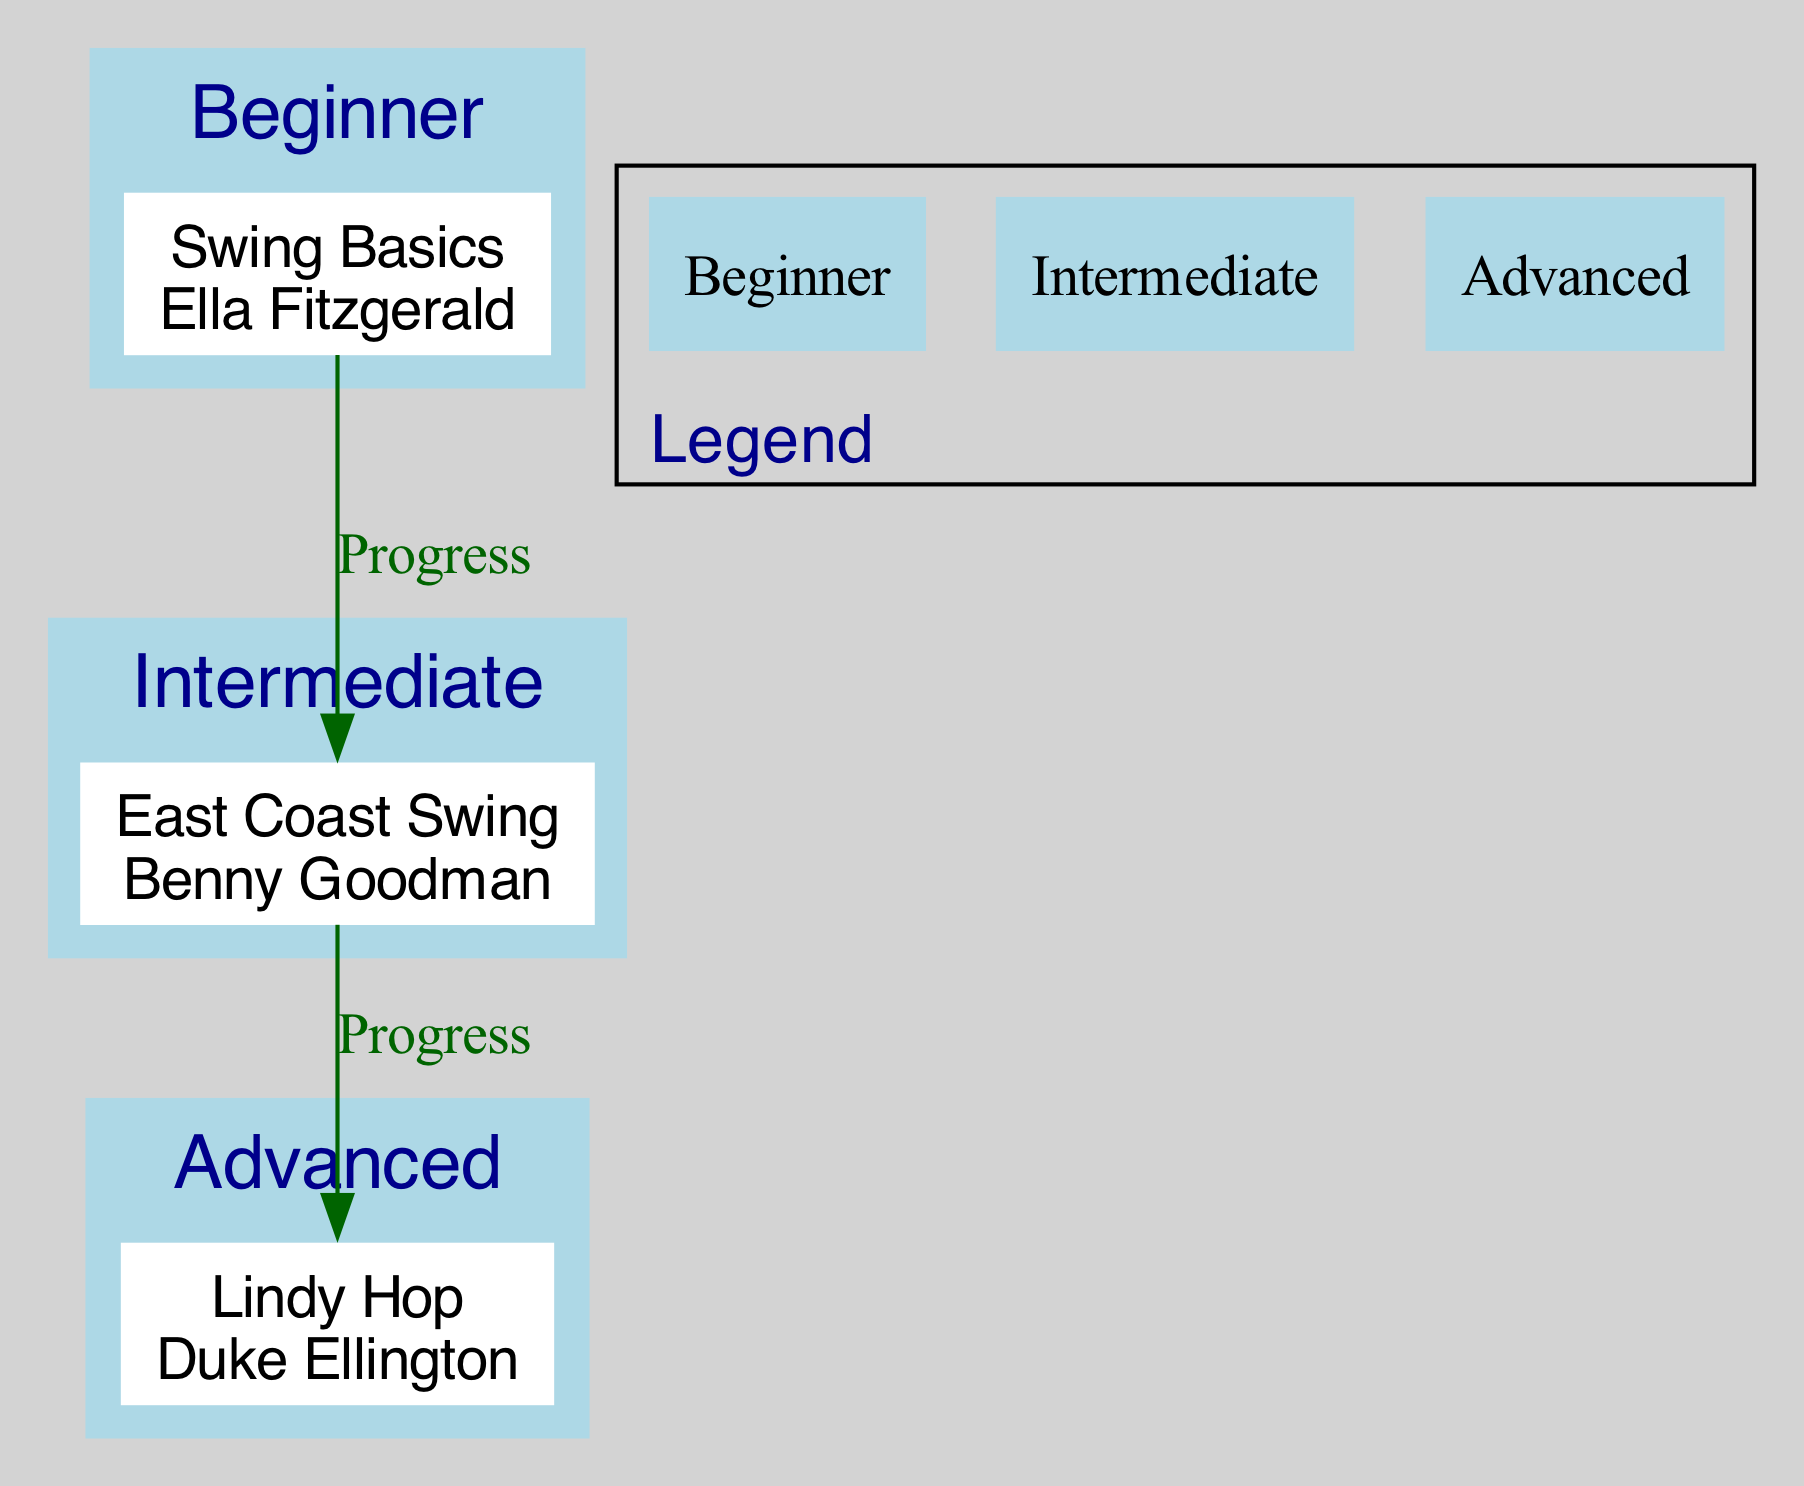What class is assigned to the instructor Ella Fitzgerald? The diagram indicates that Ella Fitzgerald is assigned to the class "Swing Basics," which is noted directly beside her name in the node.
Answer: Swing Basics How many classes are there in the Intermediate level? From the diagram, I can see one class listed under Intermediate, which is "East Coast Swing." Counting reveals that there is only one class in this level.
Answer: 1 Which class follows the East Coast Swing? The diagram shows a directed edge from "East Coast Swing" to "Lindy Hop," indicating that "Lindy Hop" is the class that follows next in terms of progression.
Answer: Lindy Hop What is the specialty of Benny Goodman? The specialty associated with Benny Goodman is listed in the tooltip of the "East Coast Swing" class node, which is "East Coast Swing and Improvisation." Thus, that's his specialty.
Answer: East Coast Swing and Improvisation Which level comes before Advanced? The diagram connects the "East Coast Swing" class to the "Lindy Hop" class under Advanced through progression, indicating that Intermediate (the level of "East Coast Swing") comes before Advanced.
Answer: Intermediate How many edges are in the diagram? By examining the connections, there are two edges illustrated: one from "Swing Basics" to "East Coast Swing" and another from "East Coast Swing" to "Lindy Hop." Totaling these connections results in two edges overall.
Answer: 2 What is the description for the Beginner level? The description for the Beginner level is directly listed in its section of the diagram as "Introduction to foundational swing dance steps." This straightforwardly describes what the beginner level entails.
Answer: Introduction to foundational swing dance steps What dance class is at the Advanced level? The diagram shows only one class listed under the Advanced level, which is "Lindy Hop." This class is designated as belonging to the Advanced level based on its grouping in the directed graph.
Answer: Lindy Hop 